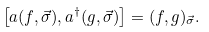<formula> <loc_0><loc_0><loc_500><loc_500>\left [ a ( f , \vec { \sigma } ) , a ^ { \dagger } ( g , \vec { \sigma } ) \right ] = ( f , g ) _ { \vec { \sigma } } .</formula> 